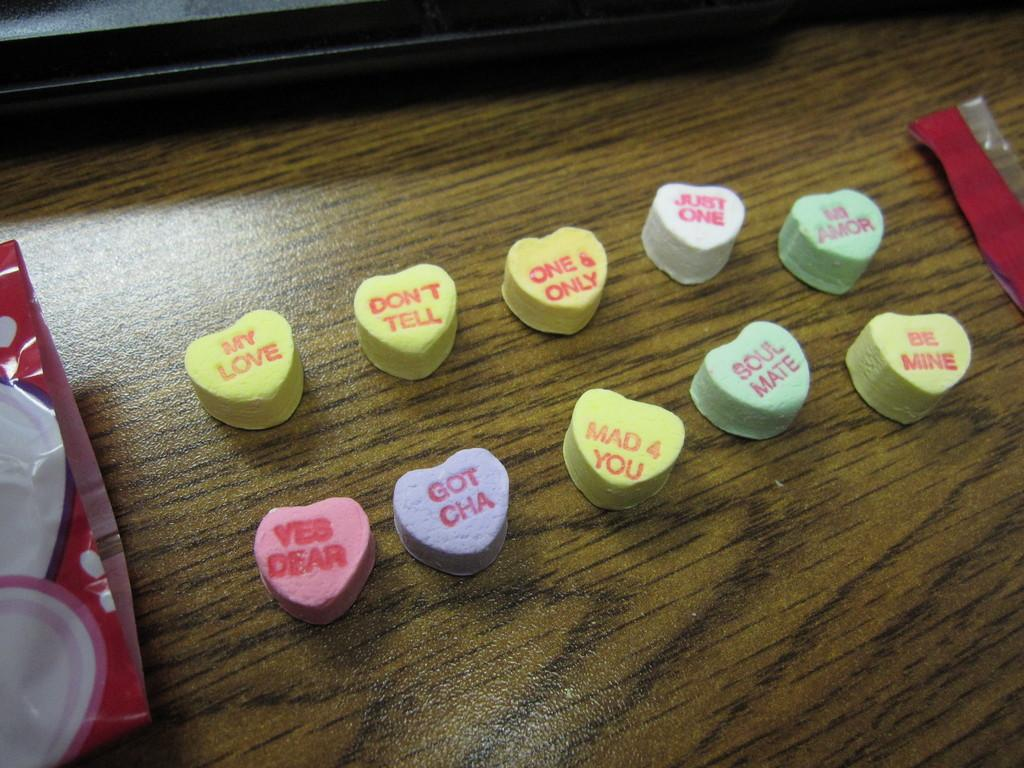What type of candies are in the image? There are heart-shaped candies in the image. What is the surface on which the candies are placed? The candies are on a wooden table. Is there anything else visible beside the candies on the table? Yes, there is a cover beside the candies on the left side of the table. What flavor of water can be seen in the image? There is no water present in the image, so it is not possible to determine the flavor of any water. 